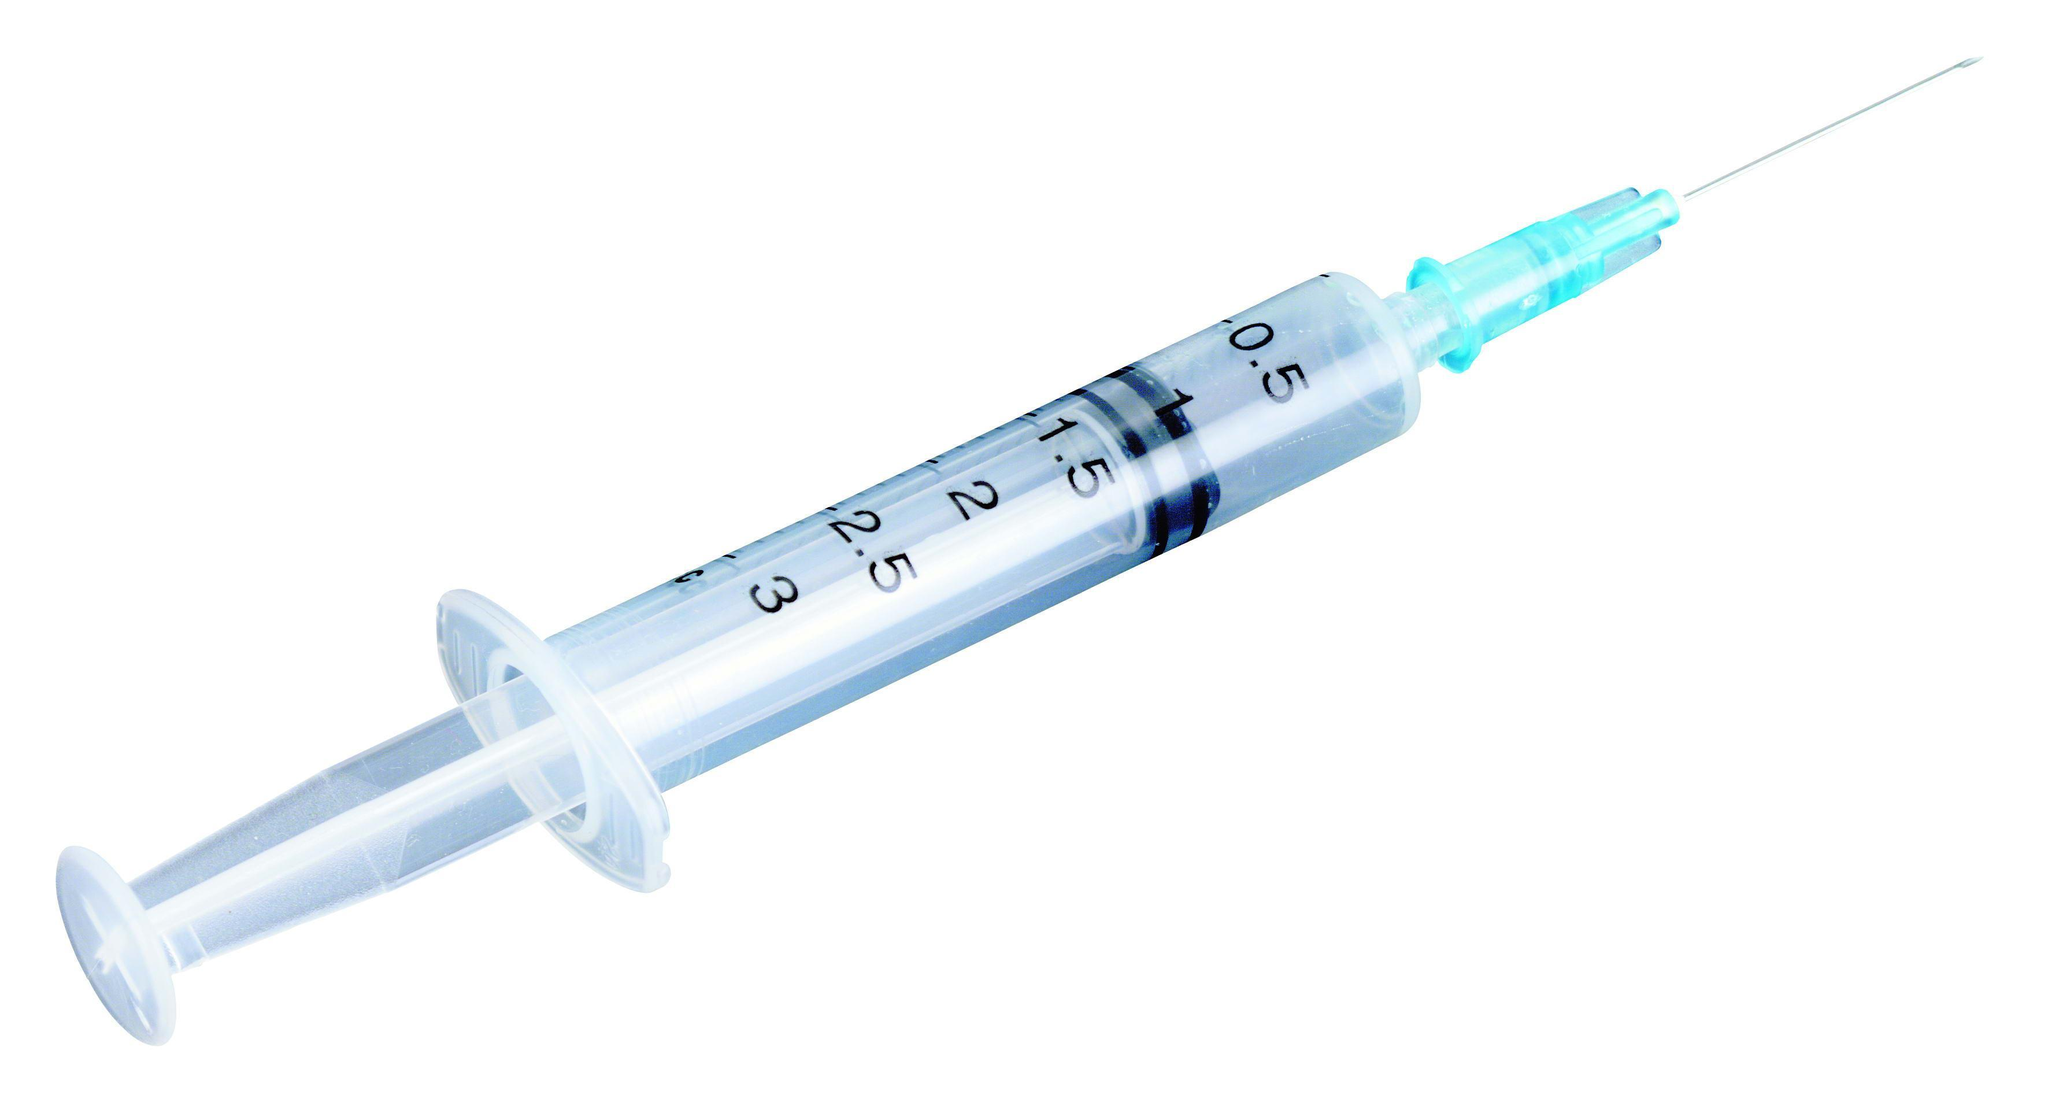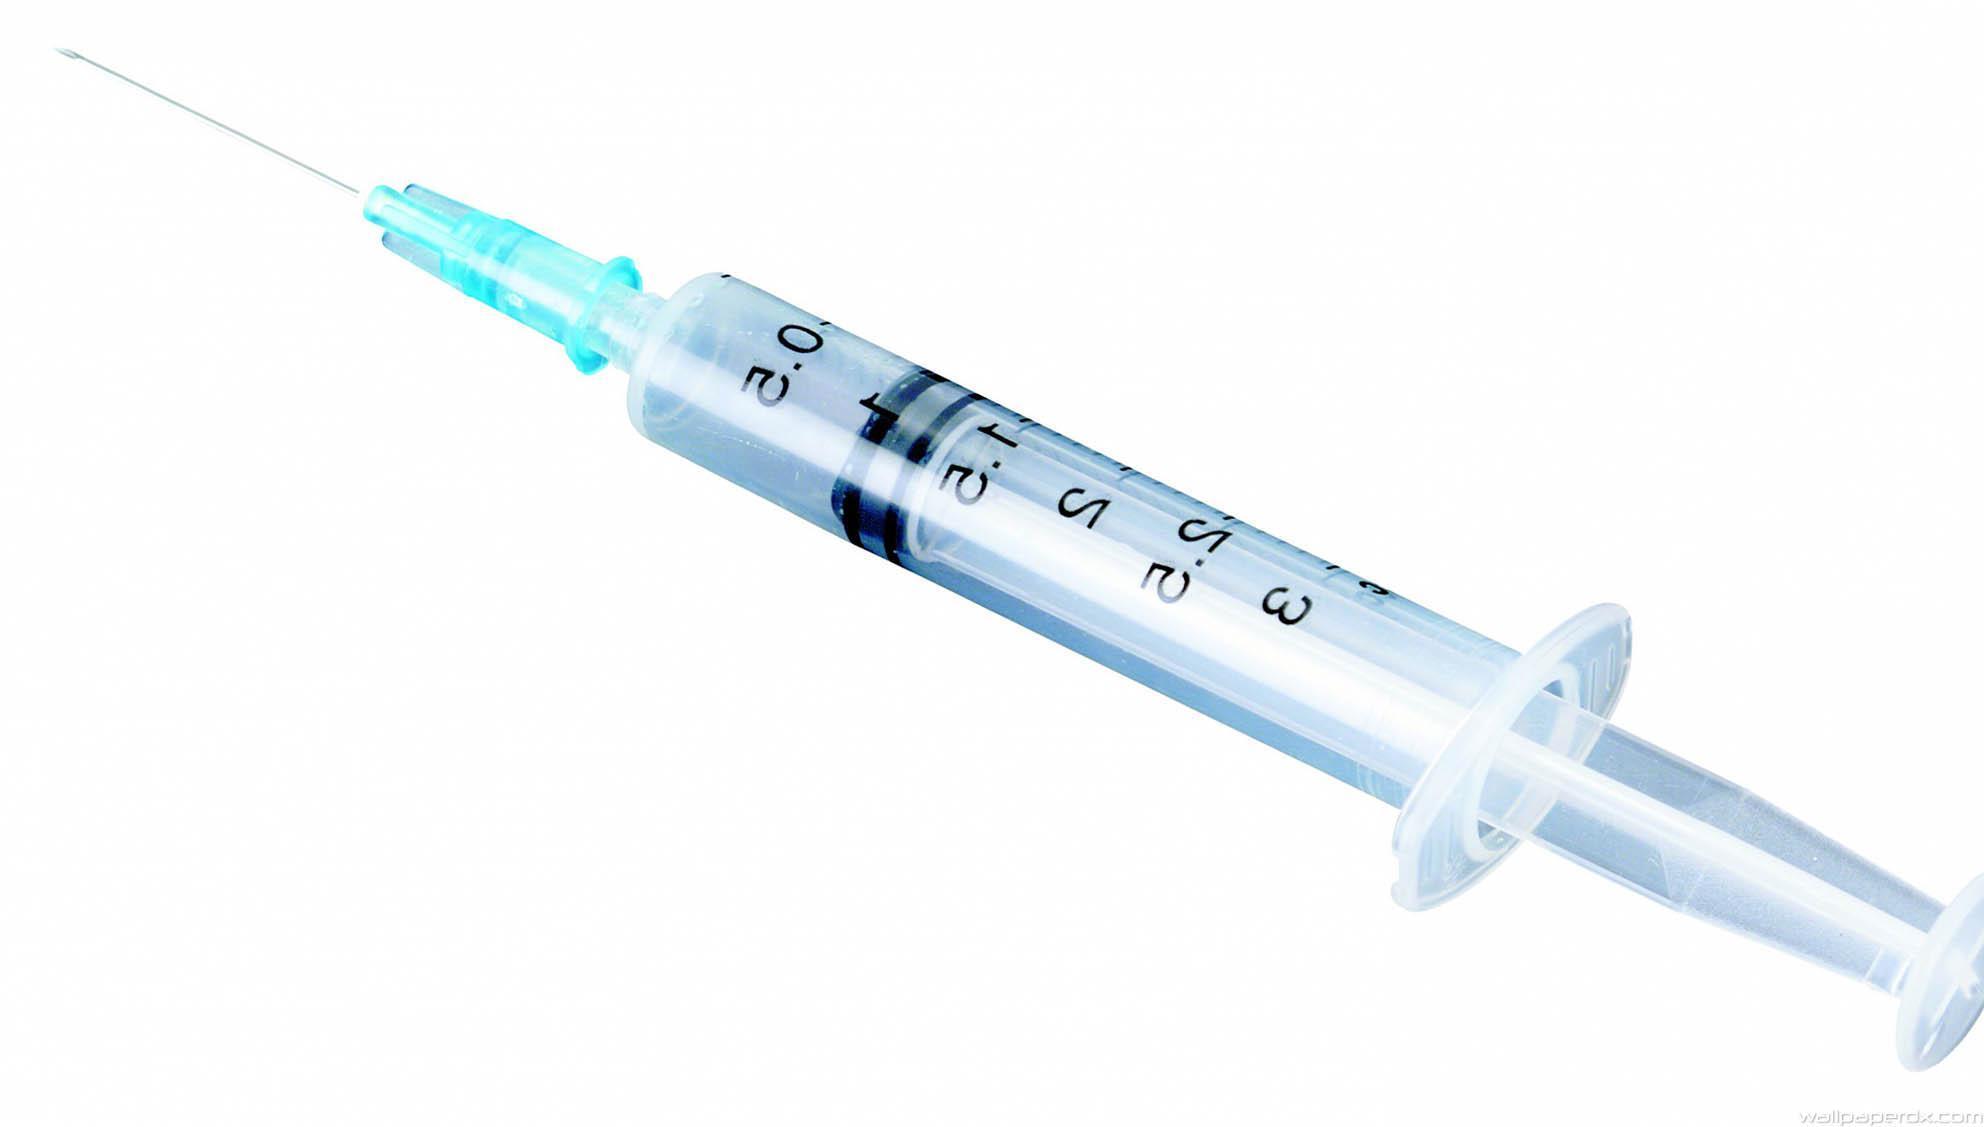The first image is the image on the left, the second image is the image on the right. Evaluate the accuracy of this statement regarding the images: "A syringe is laying on a table.". Is it true? Answer yes or no. No. 